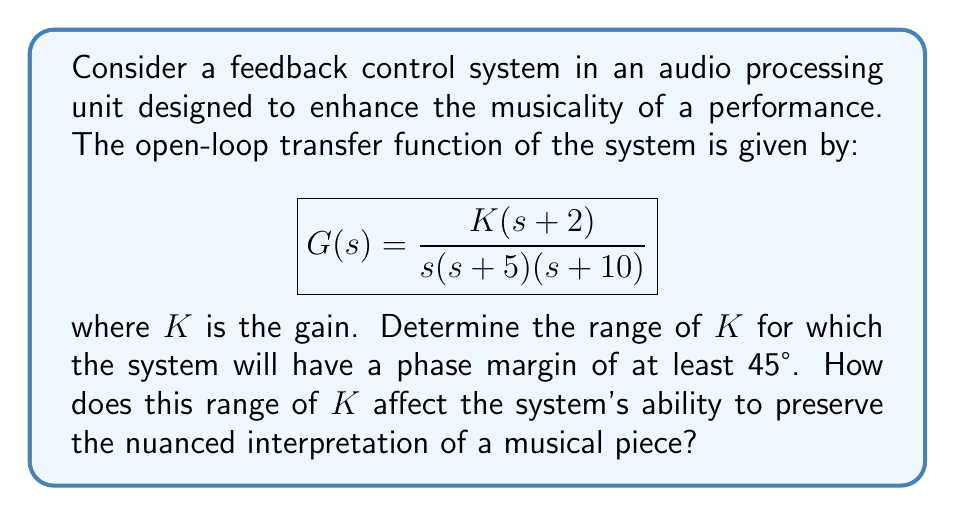Can you solve this math problem? To solve this problem, we need to follow these steps:

1) First, we need to find the crossover frequency $\omega_c$ where the magnitude of the open-loop transfer function is unity.

2) At this frequency, we calculate the phase of the system.

3) The phase margin is the amount by which the phase at $\omega_c$ exceeds -180°.

4) We set this equal to 45° and solve for $K$.

Let's begin:

1) The magnitude of $G(j\omega)$ at $\omega_c$ should be 1:

   $$|G(j\omega_c)| = \frac{K\sqrt{\omega_c^2+4}}{\omega_c\sqrt{\omega_c^2+25}\sqrt{\omega_c^2+100}} = 1$$

2) The phase of $G(j\omega)$ at $\omega_c$ is:

   $$\angle G(j\omega_c) = \tan^{-1}(\frac{2}{\omega_c}) - 90° - \tan^{-1}(\frac{\omega_c}{5}) - \tan^{-1}(\frac{\omega_c}{10})$$

3) For a phase margin of 45°, we need:

   $$\angle G(j\omega_c) = -135°$$

4) Combining steps 2 and 3:

   $$\tan^{-1}(\frac{2}{\omega_c}) - 90° - \tan^{-1}(\frac{\omega_c}{5}) - \tan^{-1}(\frac{\omega_c}{10}) = -135°$$

5) Solving this equation numerically, we get:

   $$\omega_c \approx 3.69 \text{ rad/s}$$

6) Substituting this back into the equation from step 1:

   $$K = \frac{3.69\sqrt{3.69^2+25}\sqrt{3.69^2+100}}{\sqrt{3.69^2+4}} \approx 46.8$$

This is the maximum value of $K$ that ensures a phase margin of at least 45°. The minimum value of $K$ is 0.

Regarding the system's ability to preserve nuanced interpretation:
- Lower $K$ values (closer to 0) will result in a more conservative system that doesn't significantly alter the original signal, preserving nuances but potentially not addressing issues.
- Higher $K$ values (closer to 46.8) will result in a more aggressive system that significantly modifies the signal, potentially enhancing certain aspects but risking the loss of subtle nuances in the original performance.
Answer: The range of $K$ for a phase margin of at least 45° is $0 < K \leq 46.8$. Lower $K$ values within this range will better preserve nuanced interpretations but may not significantly enhance the audio, while higher $K$ values will more aggressively modify the signal, potentially enhancing certain aspects but risking the loss of subtle nuances. 